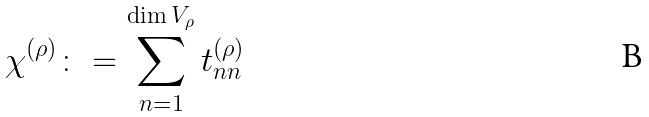<formula> <loc_0><loc_0><loc_500><loc_500>\chi ^ { ( \rho ) } \colon = \sum _ { n = 1 } ^ { \dim V _ { \rho } } t ^ { ( \rho ) } _ { n n }</formula> 